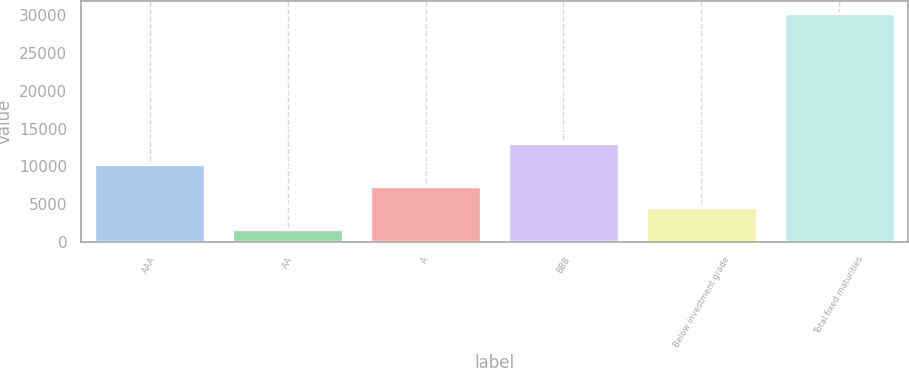<chart> <loc_0><loc_0><loc_500><loc_500><bar_chart><fcel>AAA<fcel>AA<fcel>A<fcel>BBB<fcel>Below investment grade<fcel>Total fixed maturities<nl><fcel>10282.5<fcel>1707<fcel>7424<fcel>13141<fcel>4565.5<fcel>30292<nl></chart> 